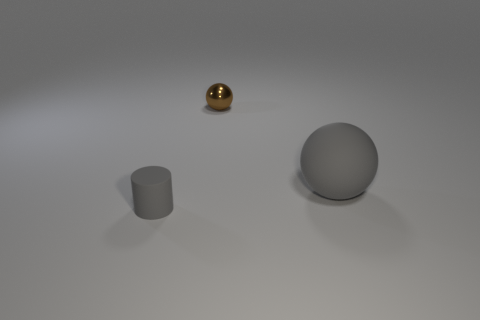Add 1 small purple objects. How many objects exist? 4 Subtract all balls. How many objects are left? 1 Add 1 small metallic balls. How many small metallic balls exist? 2 Subtract 0 red cylinders. How many objects are left? 3 Subtract all small gray cylinders. Subtract all small rubber objects. How many objects are left? 1 Add 1 gray matte things. How many gray matte things are left? 3 